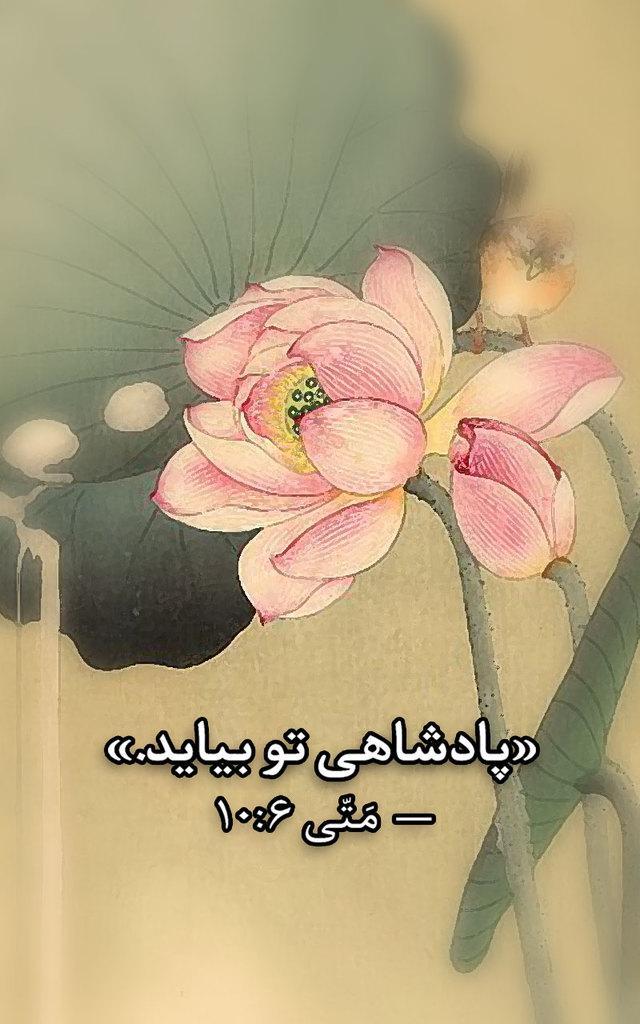Could you give a brief overview of what you see in this image? This is an edited image. On the right we can see the picture of a flower and a bird and we can see the picture of the plant and there is a bird standing on the stem of a plant. At the bottom there is a text on the image. 